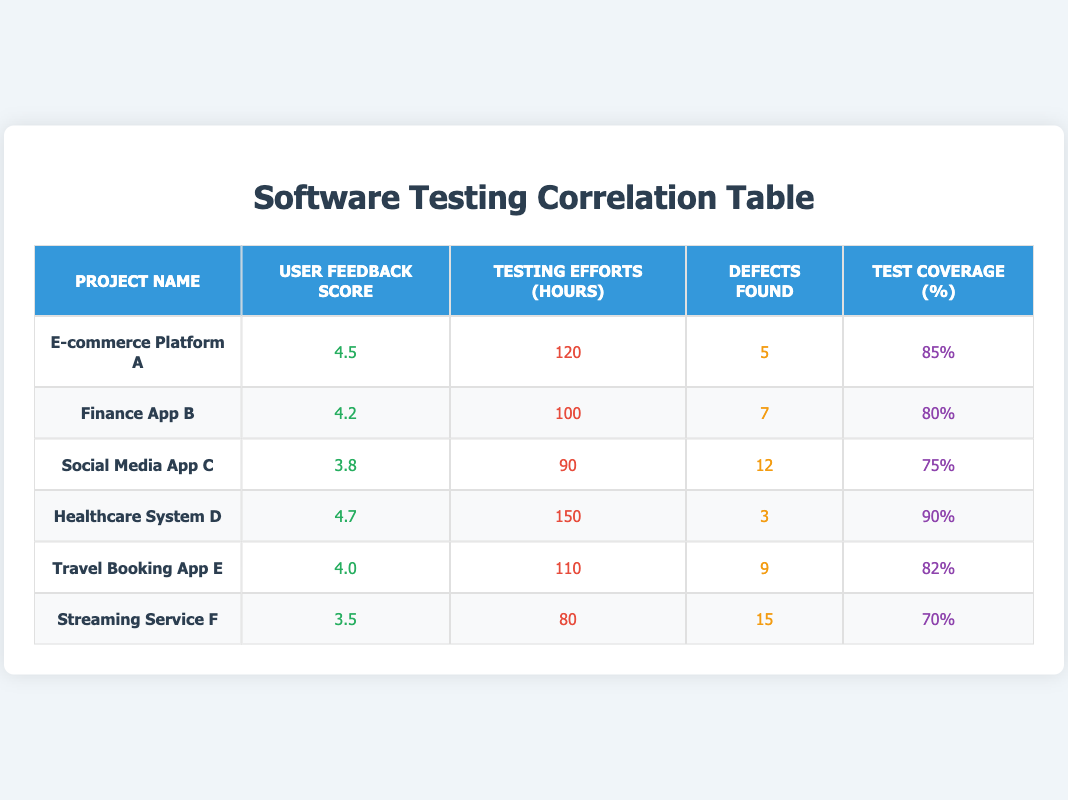What is the user feedback score for Healthcare System D? The table shows that the user feedback score for Healthcare System D is clearly indicated in the respective column. It reads 4.7.
Answer: 4.7 Which project had the highest number of defects found? By examining the "Defects Found" column, Streaming Service F has the highest number of defects at 15, compared to other projects.
Answer: Streaming Service F What is the average testing effort in hours across all projects? To find the average testing effort, we sum the testing hours: 120 + 100 + 90 + 150 + 110 + 80 = 650 hours. There are 6 projects, so the average is 650/6 ≈ 108.33.
Answer: 108.33 Did the project with the lowest User Feedback Score also have the highest number of defects found? Streaming Service F has the lowest User Feedback Score of 3.5, and it has 15 defects. Since it matches our condition where it has the highest number of defects found (which is 15), the answer is true.
Answer: Yes If we filter for projects with user feedback scores of 4 or higher, how many defects were found in total? The projects with feedback scores of 4 or higher are E-commerce Platform A (5 defects), Finance App B (7 defects), Healthcare System D (3 defects), and Travel Booking App E (9 defects). Summing those gives us 5 + 7 + 3 + 9 = 24.
Answer: 24 Which project had the best balance of user feedback score and testing hours? To find the best balance, we evaluate the User Feedback Score in relation to Testing Efforts (hours). Healthcare System D has a score of 4.7 with 150 hours, and it has fewer defects (3) compared to its high score, suggesting a good balance among the projects.
Answer: Healthcare System D How does the test coverage percentage for Finance App B compare to that of Social Media App C? Finance App B has a test coverage percentage of 80%, while Social Media App C has a coverage of 75%. Therefore, Finance App B has a higher test coverage by 5%.
Answer: Finance App B What is the total number of defects found in projects with test coverage above 80%? The projects with test coverage above 80% are E-commerce Platform A (5 defects), Healthcare System D (3 defects), and Travel Booking App E (9 defects). Adding these gives us 5 + 3 + 9 = 17 defects found in total.
Answer: 17 Does increasing testing hours correlate with higher user feedback scores? Looking at the data, we see that increasing testing hours does not consistently yield higher user feedback scores. For example, Healthcare System D with more testing hours (150) has a high score (4.7), whereas Streaming Service F with fewer hours (80) has the lowest score (3.5). This suggests that correlation may not be straightforward.
Answer: No 